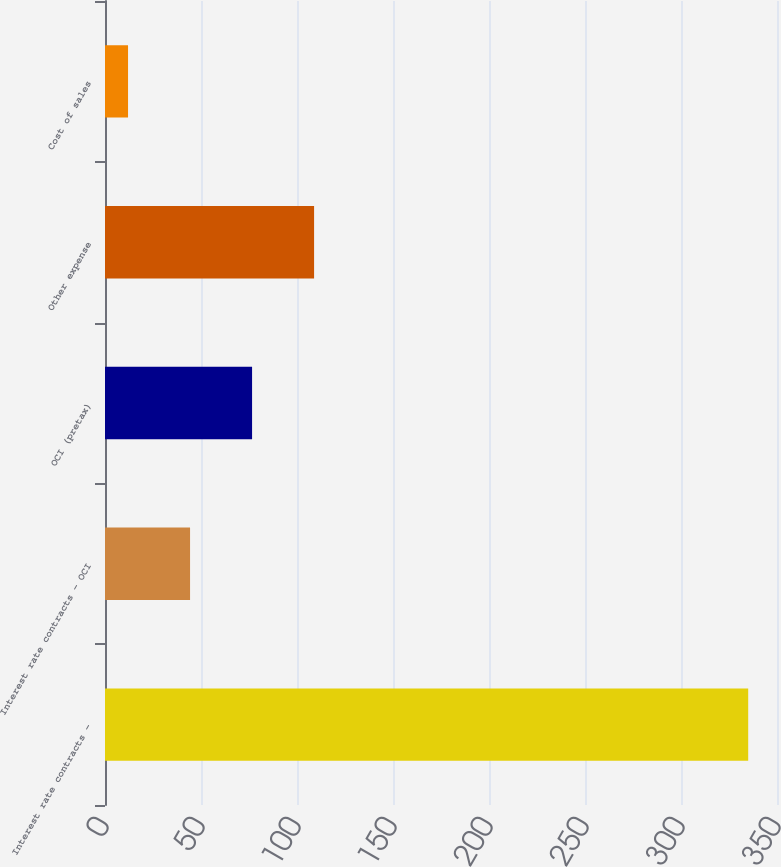Convert chart to OTSL. <chart><loc_0><loc_0><loc_500><loc_500><bar_chart><fcel>Interest rate contracts -<fcel>Interest rate contracts - OCI<fcel>OCI (pretax)<fcel>Other expense<fcel>Cost of sales<nl><fcel>335<fcel>44.3<fcel>76.6<fcel>108.9<fcel>12<nl></chart> 